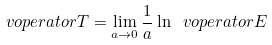<formula> <loc_0><loc_0><loc_500><loc_500>\ v o p e r a t o r { T } = \lim _ { a \to 0 } \frac { 1 } { a } \ln \ v o p e r a t o r { E }</formula> 